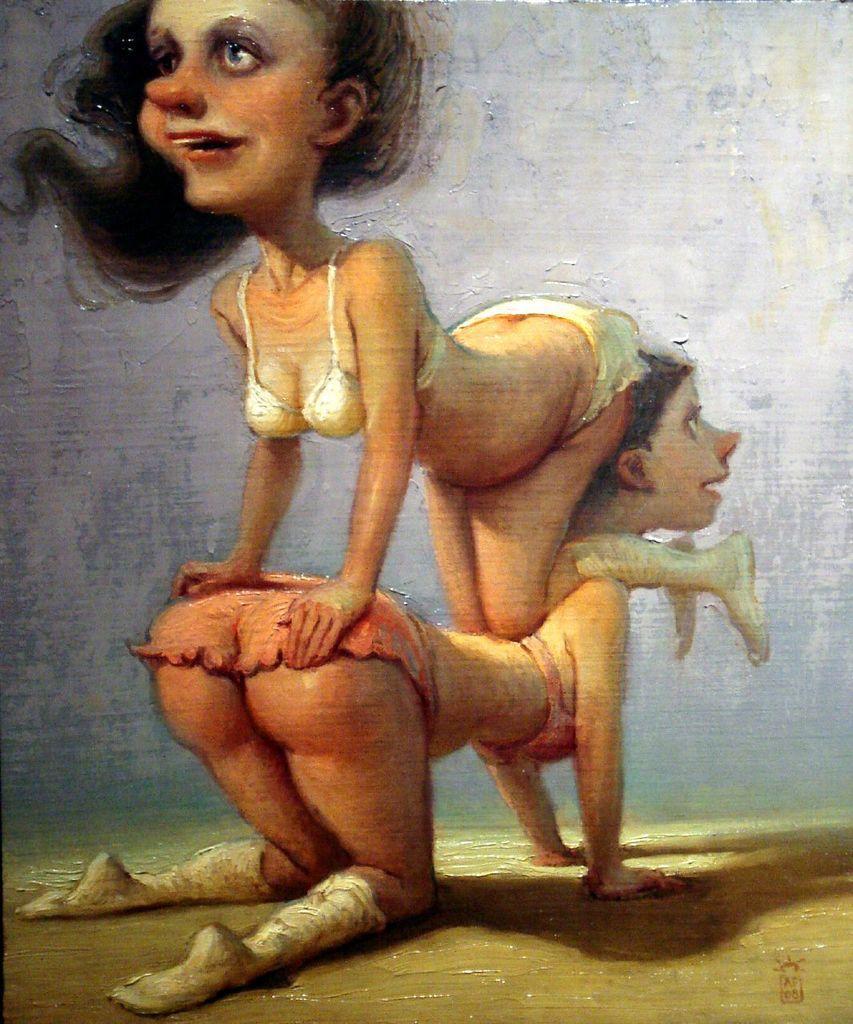In one or two sentences, can you explain what this image depicts? In this image I can see two women´s paintings and a wall. This image looks like a photo frame. 